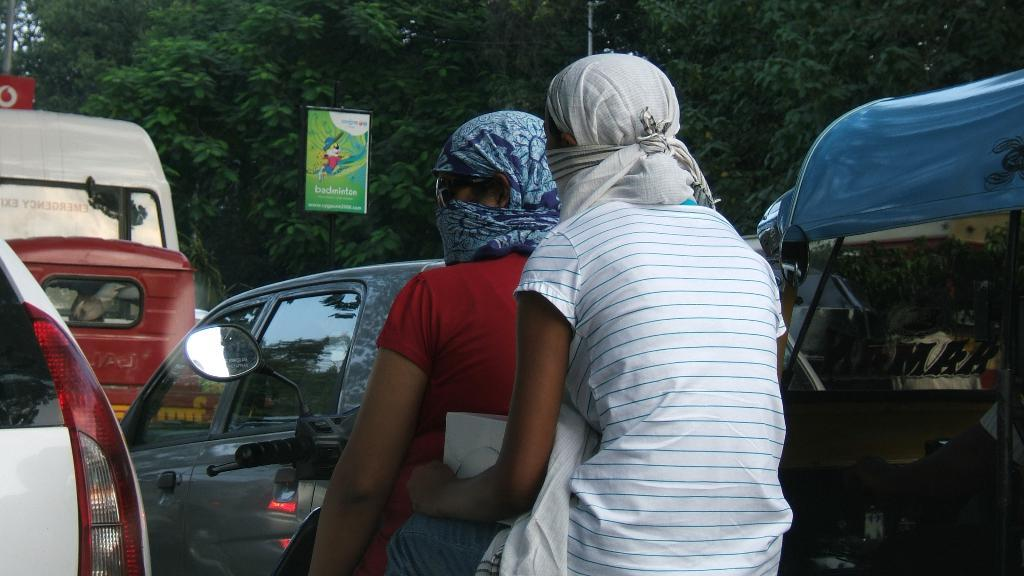What can be seen in the image? There is a group of vehicles in the image. Can you describe the women in the foreground? There are two women sitting on a bike in the foreground. What is visible in the background of the image? There are trees, a board, and a pole in the background of the image. What verse is being recited by the women on the bike? There is no indication in the image that the women are reciting a verse, so it cannot be determined from the picture. 